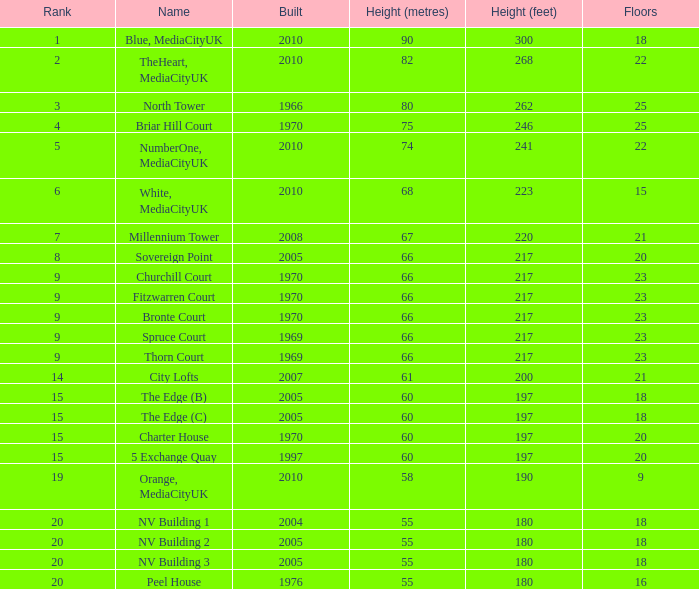What is Height, when Rank is less than 20, when Floors is greater than 9, when Built is 2005, and when Name is The Edge (C)? 60 metres (197ft). 